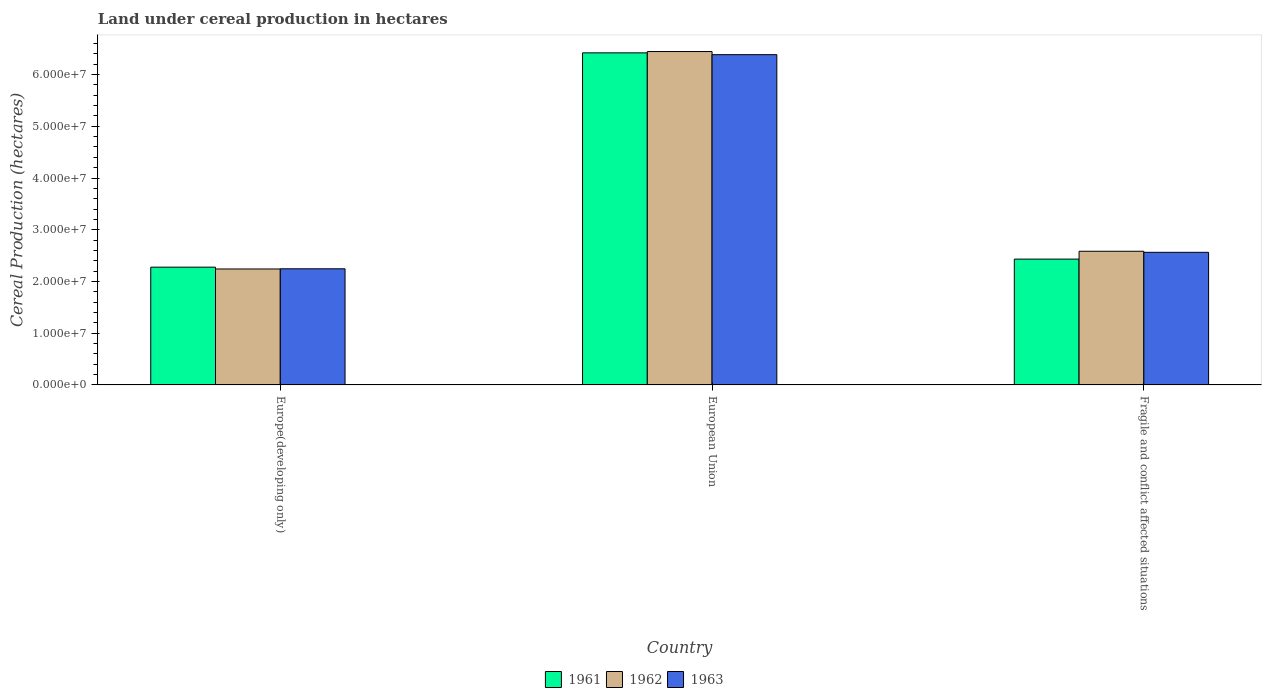How many different coloured bars are there?
Keep it short and to the point. 3. Are the number of bars per tick equal to the number of legend labels?
Your answer should be very brief. Yes. Are the number of bars on each tick of the X-axis equal?
Offer a very short reply. Yes. How many bars are there on the 2nd tick from the left?
Give a very brief answer. 3. How many bars are there on the 2nd tick from the right?
Your response must be concise. 3. What is the land under cereal production in 1963 in Europe(developing only)?
Make the answer very short. 2.24e+07. Across all countries, what is the maximum land under cereal production in 1961?
Keep it short and to the point. 6.42e+07. Across all countries, what is the minimum land under cereal production in 1961?
Offer a very short reply. 2.28e+07. In which country was the land under cereal production in 1961 maximum?
Give a very brief answer. European Union. In which country was the land under cereal production in 1961 minimum?
Your answer should be compact. Europe(developing only). What is the total land under cereal production in 1963 in the graph?
Offer a very short reply. 1.12e+08. What is the difference between the land under cereal production in 1963 in Europe(developing only) and that in European Union?
Provide a succinct answer. -4.14e+07. What is the difference between the land under cereal production in 1963 in Europe(developing only) and the land under cereal production in 1961 in European Union?
Keep it short and to the point. -4.17e+07. What is the average land under cereal production in 1963 per country?
Your response must be concise. 3.73e+07. What is the difference between the land under cereal production of/in 1961 and land under cereal production of/in 1963 in European Union?
Your response must be concise. 3.52e+05. In how many countries, is the land under cereal production in 1961 greater than 50000000 hectares?
Provide a short and direct response. 1. What is the ratio of the land under cereal production in 1962 in Europe(developing only) to that in European Union?
Your answer should be very brief. 0.35. Is the difference between the land under cereal production in 1961 in European Union and Fragile and conflict affected situations greater than the difference between the land under cereal production in 1963 in European Union and Fragile and conflict affected situations?
Your answer should be compact. Yes. What is the difference between the highest and the second highest land under cereal production in 1962?
Make the answer very short. -4.20e+07. What is the difference between the highest and the lowest land under cereal production in 1961?
Make the answer very short. 4.14e+07. In how many countries, is the land under cereal production in 1962 greater than the average land under cereal production in 1962 taken over all countries?
Provide a short and direct response. 1. What does the 1st bar from the right in European Union represents?
Ensure brevity in your answer.  1963. How many countries are there in the graph?
Ensure brevity in your answer.  3. What is the difference between two consecutive major ticks on the Y-axis?
Your answer should be very brief. 1.00e+07. Are the values on the major ticks of Y-axis written in scientific E-notation?
Your answer should be very brief. Yes. Does the graph contain any zero values?
Provide a succinct answer. No. How are the legend labels stacked?
Provide a short and direct response. Horizontal. What is the title of the graph?
Provide a short and direct response. Land under cereal production in hectares. Does "1991" appear as one of the legend labels in the graph?
Your answer should be compact. No. What is the label or title of the X-axis?
Make the answer very short. Country. What is the label or title of the Y-axis?
Your response must be concise. Cereal Production (hectares). What is the Cereal Production (hectares) of 1961 in Europe(developing only)?
Your answer should be very brief. 2.28e+07. What is the Cereal Production (hectares) of 1962 in Europe(developing only)?
Your answer should be compact. 2.24e+07. What is the Cereal Production (hectares) of 1963 in Europe(developing only)?
Offer a terse response. 2.24e+07. What is the Cereal Production (hectares) of 1961 in European Union?
Your answer should be very brief. 6.42e+07. What is the Cereal Production (hectares) of 1962 in European Union?
Offer a very short reply. 6.44e+07. What is the Cereal Production (hectares) of 1963 in European Union?
Your response must be concise. 6.38e+07. What is the Cereal Production (hectares) of 1961 in Fragile and conflict affected situations?
Offer a terse response. 2.43e+07. What is the Cereal Production (hectares) of 1962 in Fragile and conflict affected situations?
Make the answer very short. 2.58e+07. What is the Cereal Production (hectares) of 1963 in Fragile and conflict affected situations?
Your answer should be very brief. 2.56e+07. Across all countries, what is the maximum Cereal Production (hectares) in 1961?
Provide a succinct answer. 6.42e+07. Across all countries, what is the maximum Cereal Production (hectares) of 1962?
Provide a short and direct response. 6.44e+07. Across all countries, what is the maximum Cereal Production (hectares) in 1963?
Provide a short and direct response. 6.38e+07. Across all countries, what is the minimum Cereal Production (hectares) in 1961?
Your response must be concise. 2.28e+07. Across all countries, what is the minimum Cereal Production (hectares) in 1962?
Offer a very short reply. 2.24e+07. Across all countries, what is the minimum Cereal Production (hectares) of 1963?
Your answer should be very brief. 2.24e+07. What is the total Cereal Production (hectares) of 1961 in the graph?
Your response must be concise. 1.11e+08. What is the total Cereal Production (hectares) in 1962 in the graph?
Provide a succinct answer. 1.13e+08. What is the total Cereal Production (hectares) in 1963 in the graph?
Provide a short and direct response. 1.12e+08. What is the difference between the Cereal Production (hectares) in 1961 in Europe(developing only) and that in European Union?
Offer a terse response. -4.14e+07. What is the difference between the Cereal Production (hectares) of 1962 in Europe(developing only) and that in European Union?
Offer a terse response. -4.20e+07. What is the difference between the Cereal Production (hectares) in 1963 in Europe(developing only) and that in European Union?
Offer a terse response. -4.14e+07. What is the difference between the Cereal Production (hectares) of 1961 in Europe(developing only) and that in Fragile and conflict affected situations?
Keep it short and to the point. -1.56e+06. What is the difference between the Cereal Production (hectares) of 1962 in Europe(developing only) and that in Fragile and conflict affected situations?
Your response must be concise. -3.43e+06. What is the difference between the Cereal Production (hectares) in 1963 in Europe(developing only) and that in Fragile and conflict affected situations?
Offer a terse response. -3.18e+06. What is the difference between the Cereal Production (hectares) in 1961 in European Union and that in Fragile and conflict affected situations?
Give a very brief answer. 3.99e+07. What is the difference between the Cereal Production (hectares) of 1962 in European Union and that in Fragile and conflict affected situations?
Your response must be concise. 3.86e+07. What is the difference between the Cereal Production (hectares) of 1963 in European Union and that in Fragile and conflict affected situations?
Your response must be concise. 3.82e+07. What is the difference between the Cereal Production (hectares) in 1961 in Europe(developing only) and the Cereal Production (hectares) in 1962 in European Union?
Offer a very short reply. -4.17e+07. What is the difference between the Cereal Production (hectares) of 1961 in Europe(developing only) and the Cereal Production (hectares) of 1963 in European Union?
Give a very brief answer. -4.11e+07. What is the difference between the Cereal Production (hectares) in 1962 in Europe(developing only) and the Cereal Production (hectares) in 1963 in European Union?
Offer a terse response. -4.14e+07. What is the difference between the Cereal Production (hectares) of 1961 in Europe(developing only) and the Cereal Production (hectares) of 1962 in Fragile and conflict affected situations?
Provide a short and direct response. -3.08e+06. What is the difference between the Cereal Production (hectares) of 1961 in Europe(developing only) and the Cereal Production (hectares) of 1963 in Fragile and conflict affected situations?
Provide a succinct answer. -2.87e+06. What is the difference between the Cereal Production (hectares) in 1962 in Europe(developing only) and the Cereal Production (hectares) in 1963 in Fragile and conflict affected situations?
Your response must be concise. -3.22e+06. What is the difference between the Cereal Production (hectares) in 1961 in European Union and the Cereal Production (hectares) in 1962 in Fragile and conflict affected situations?
Provide a short and direct response. 3.84e+07. What is the difference between the Cereal Production (hectares) in 1961 in European Union and the Cereal Production (hectares) in 1963 in Fragile and conflict affected situations?
Your response must be concise. 3.86e+07. What is the difference between the Cereal Production (hectares) of 1962 in European Union and the Cereal Production (hectares) of 1963 in Fragile and conflict affected situations?
Ensure brevity in your answer.  3.88e+07. What is the average Cereal Production (hectares) of 1961 per country?
Offer a terse response. 3.71e+07. What is the average Cereal Production (hectares) of 1962 per country?
Your response must be concise. 3.76e+07. What is the average Cereal Production (hectares) of 1963 per country?
Provide a short and direct response. 3.73e+07. What is the difference between the Cereal Production (hectares) in 1961 and Cereal Production (hectares) in 1962 in Europe(developing only)?
Your answer should be very brief. 3.51e+05. What is the difference between the Cereal Production (hectares) of 1961 and Cereal Production (hectares) of 1963 in Europe(developing only)?
Your response must be concise. 3.14e+05. What is the difference between the Cereal Production (hectares) of 1962 and Cereal Production (hectares) of 1963 in Europe(developing only)?
Offer a terse response. -3.65e+04. What is the difference between the Cereal Production (hectares) of 1961 and Cereal Production (hectares) of 1962 in European Union?
Give a very brief answer. -2.53e+05. What is the difference between the Cereal Production (hectares) of 1961 and Cereal Production (hectares) of 1963 in European Union?
Your answer should be very brief. 3.52e+05. What is the difference between the Cereal Production (hectares) in 1962 and Cereal Production (hectares) in 1963 in European Union?
Offer a very short reply. 6.05e+05. What is the difference between the Cereal Production (hectares) of 1961 and Cereal Production (hectares) of 1962 in Fragile and conflict affected situations?
Provide a short and direct response. -1.52e+06. What is the difference between the Cereal Production (hectares) in 1961 and Cereal Production (hectares) in 1963 in Fragile and conflict affected situations?
Your answer should be compact. -1.31e+06. What is the difference between the Cereal Production (hectares) of 1962 and Cereal Production (hectares) of 1963 in Fragile and conflict affected situations?
Give a very brief answer. 2.06e+05. What is the ratio of the Cereal Production (hectares) of 1961 in Europe(developing only) to that in European Union?
Keep it short and to the point. 0.35. What is the ratio of the Cereal Production (hectares) of 1962 in Europe(developing only) to that in European Union?
Offer a terse response. 0.35. What is the ratio of the Cereal Production (hectares) in 1963 in Europe(developing only) to that in European Union?
Provide a succinct answer. 0.35. What is the ratio of the Cereal Production (hectares) of 1961 in Europe(developing only) to that in Fragile and conflict affected situations?
Ensure brevity in your answer.  0.94. What is the ratio of the Cereal Production (hectares) in 1962 in Europe(developing only) to that in Fragile and conflict affected situations?
Your response must be concise. 0.87. What is the ratio of the Cereal Production (hectares) in 1963 in Europe(developing only) to that in Fragile and conflict affected situations?
Provide a short and direct response. 0.88. What is the ratio of the Cereal Production (hectares) in 1961 in European Union to that in Fragile and conflict affected situations?
Ensure brevity in your answer.  2.64. What is the ratio of the Cereal Production (hectares) in 1962 in European Union to that in Fragile and conflict affected situations?
Provide a short and direct response. 2.49. What is the ratio of the Cereal Production (hectares) in 1963 in European Union to that in Fragile and conflict affected situations?
Provide a succinct answer. 2.49. What is the difference between the highest and the second highest Cereal Production (hectares) of 1961?
Provide a short and direct response. 3.99e+07. What is the difference between the highest and the second highest Cereal Production (hectares) in 1962?
Offer a terse response. 3.86e+07. What is the difference between the highest and the second highest Cereal Production (hectares) in 1963?
Keep it short and to the point. 3.82e+07. What is the difference between the highest and the lowest Cereal Production (hectares) in 1961?
Keep it short and to the point. 4.14e+07. What is the difference between the highest and the lowest Cereal Production (hectares) in 1962?
Provide a short and direct response. 4.20e+07. What is the difference between the highest and the lowest Cereal Production (hectares) of 1963?
Offer a terse response. 4.14e+07. 